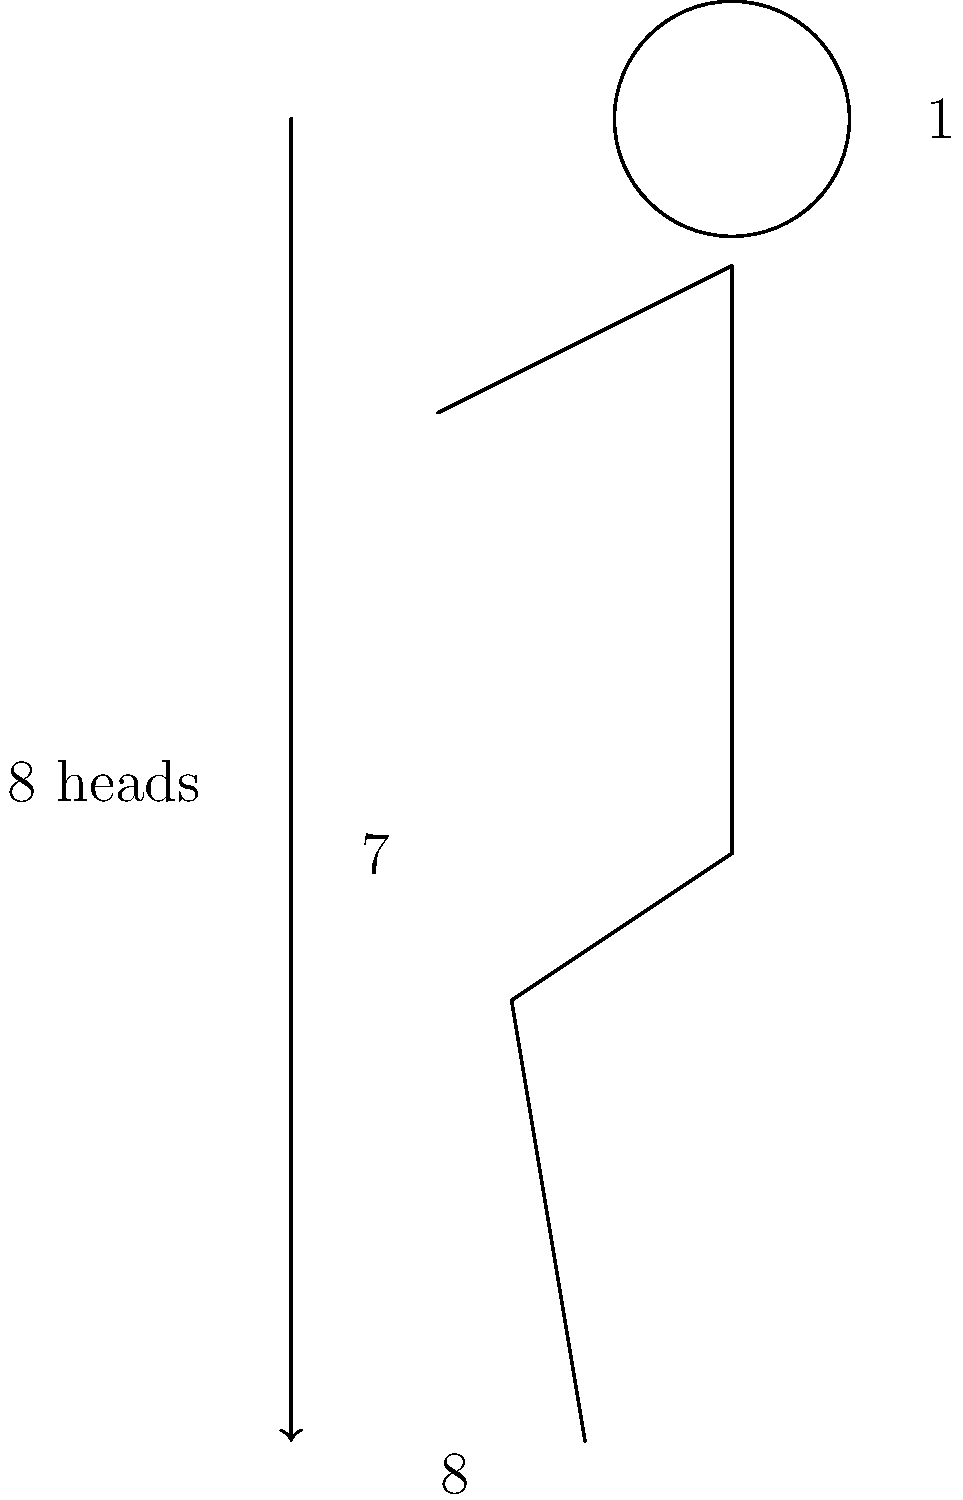In superhero character design, artists often use idealized body proportions. Based on the figure shown, which represents a common superhero body type, what is the ratio of the total body height to the head height? How does this compare to average human proportions? To answer this question, we need to analyze the proportions shown in the figure and compare them to average human proportions:

1. In the figure, we can see that the total height of the body is divided into 8 equal parts, with the head occupying the topmost part.

2. This means that the total body height is 8 times the height of the head, giving us a ratio of 8:1.

3. The label on the left side of the figure confirms this, showing "8 heads" for the total body height.

4. In contrast, average human proportions typically follow a 7.5:1 ratio, where the total body height is about 7.5 times the height of the head.

5. Superhero designs often exaggerate these proportions to create a more idealized, heroic appearance. The 8:1 ratio gives the character a slightly taller, more imposing look compared to average human proportions.

6. This elongated proportion is particularly noticeable in the torso area (from shoulders to hips), which is often drawn to be longer in superhero designs to emphasize strength and athleticism.

7. The shoulder width in the figure is also notably wide (about 3 head widths), which is another common exaggeration in superhero anatomy to convey power and strength.
Answer: 8:1 ratio, exaggerated compared to the average human 7.5:1 ratio. 